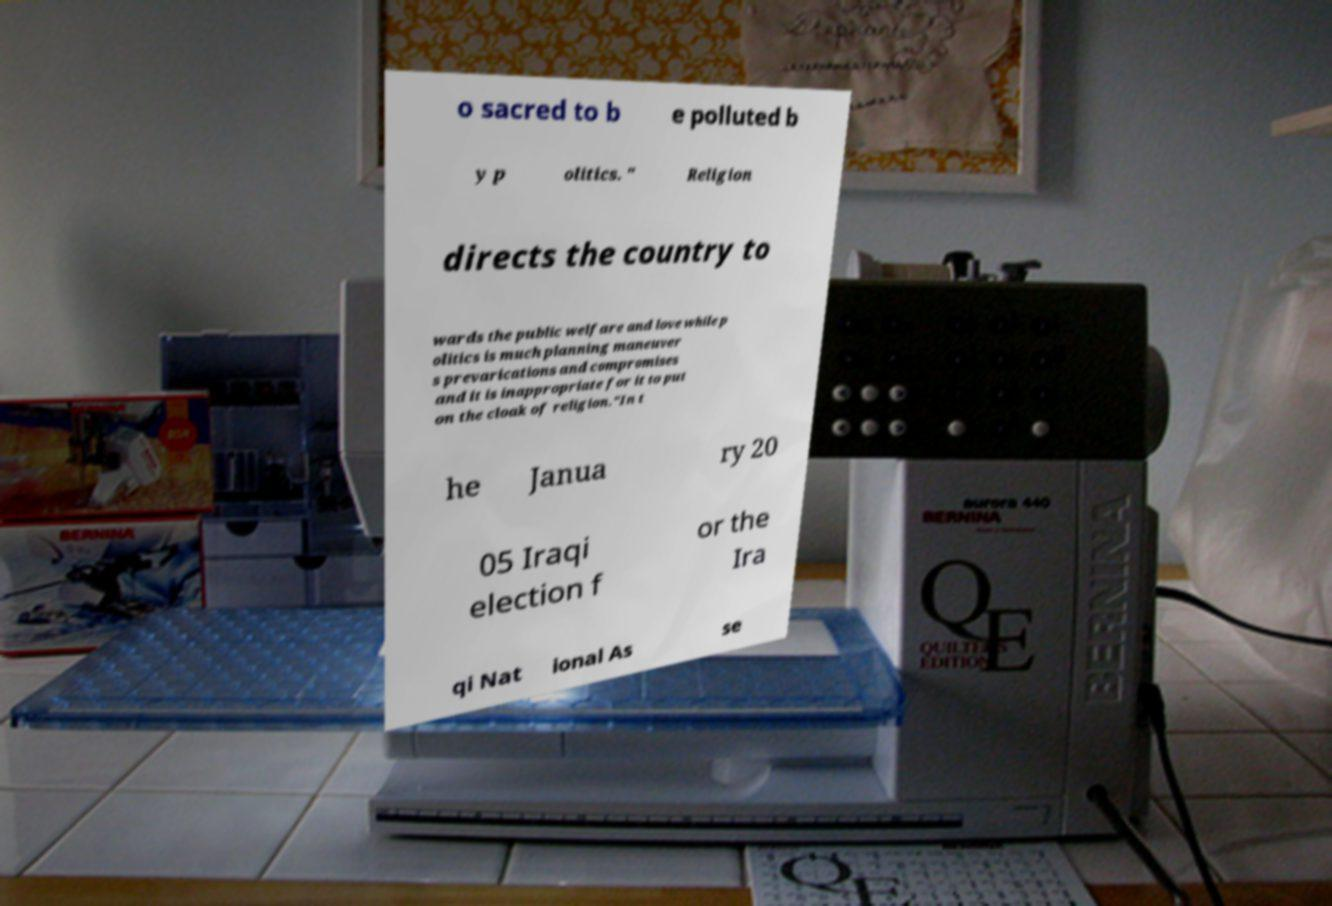Could you extract and type out the text from this image? o sacred to b e polluted b y p olitics. " Religion directs the country to wards the public welfare and love while p olitics is much planning maneuver s prevarications and compromises and it is inappropriate for it to put on the cloak of religion."In t he Janua ry 20 05 Iraqi election f or the Ira qi Nat ional As se 